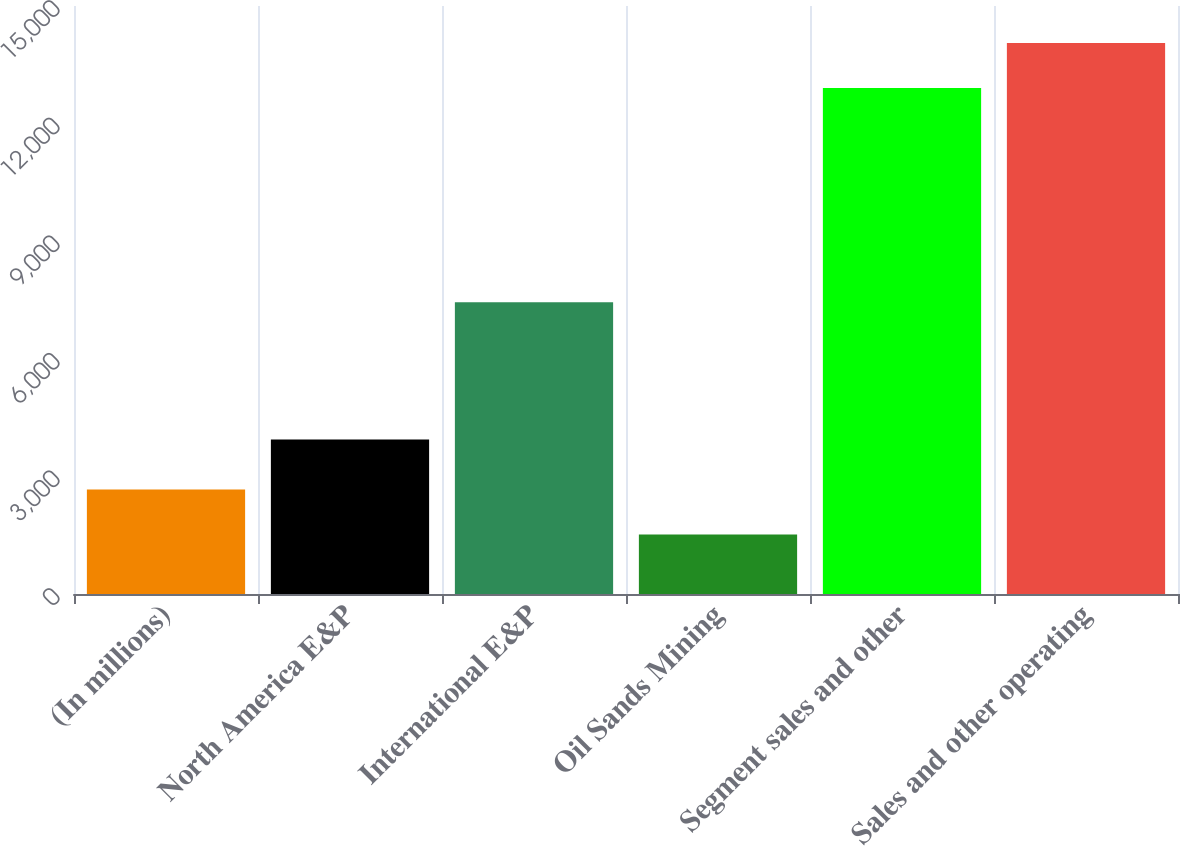Convert chart to OTSL. <chart><loc_0><loc_0><loc_500><loc_500><bar_chart><fcel>(In millions)<fcel>North America E&P<fcel>International E&P<fcel>Oil Sands Mining<fcel>Segment sales and other<fcel>Sales and other operating<nl><fcel>2665.2<fcel>3944<fcel>7445<fcel>1521<fcel>12910<fcel>14054.2<nl></chart> 